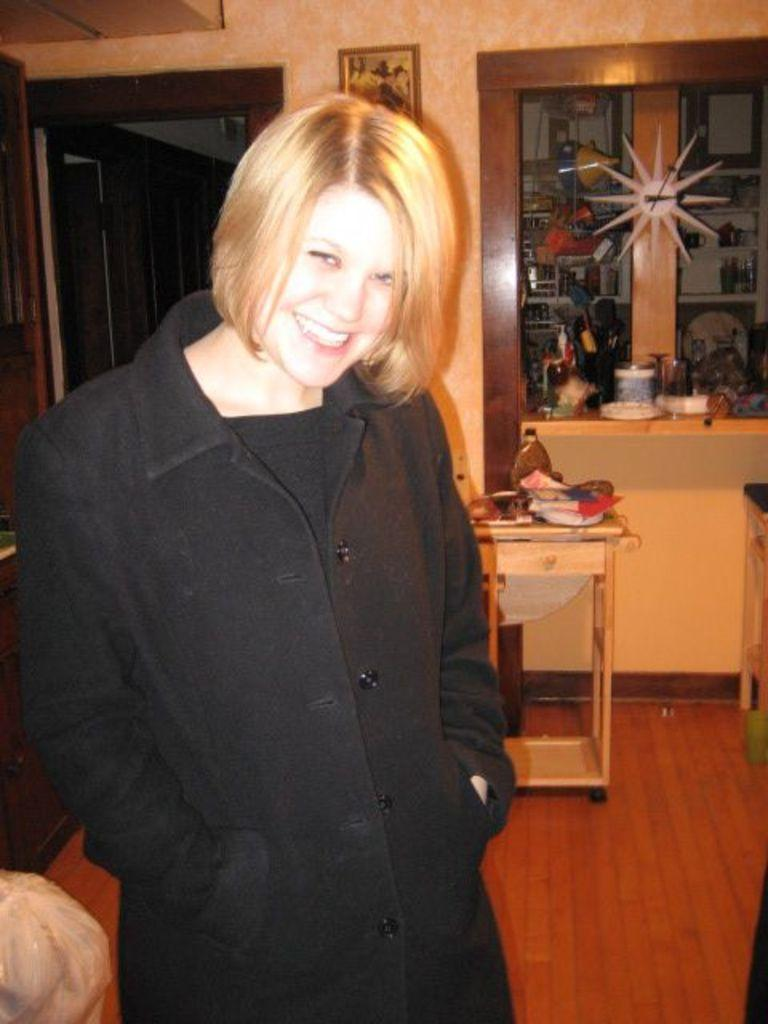Who is the main subject in the image? There is a woman in the image. What is located behind the woman? There is a door behind the woman. What can be seen on the wall behind the woman? There is a photo frame on the wall behind the woman. What type of cream is being used to paint the door in the image? There is no indication in the image that the door is being painted, nor is there any mention of cream being used for that purpose. 